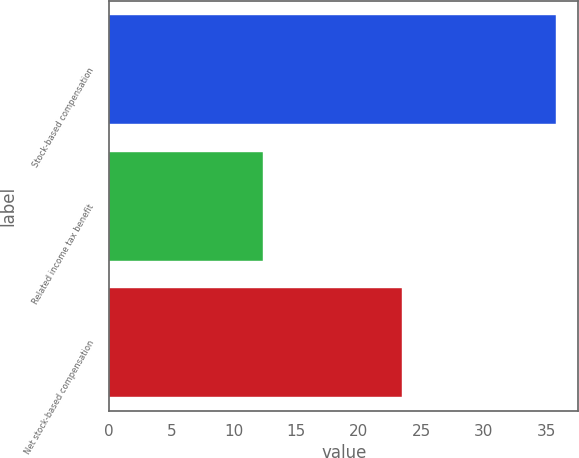<chart> <loc_0><loc_0><loc_500><loc_500><bar_chart><fcel>Stock-based compensation<fcel>Related income tax benefit<fcel>Net stock-based compensation<nl><fcel>35.8<fcel>12.3<fcel>23.5<nl></chart> 